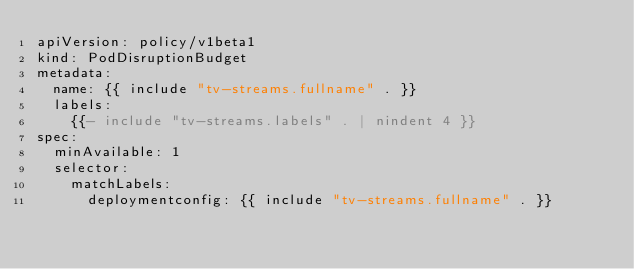Convert code to text. <code><loc_0><loc_0><loc_500><loc_500><_YAML_>apiVersion: policy/v1beta1
kind: PodDisruptionBudget
metadata:
  name: {{ include "tv-streams.fullname" . }}
  labels:
    {{- include "tv-streams.labels" . | nindent 4 }}
spec:
  minAvailable: 1
  selector:
    matchLabels:
      deploymentconfig: {{ include "tv-streams.fullname" . }}
</code> 